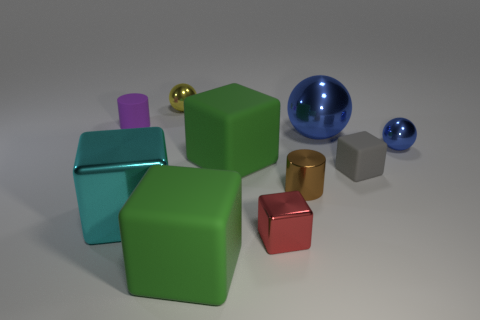There is a green thing in front of the metal thing on the left side of the small metallic thing that is behind the purple rubber thing; what is its material?
Ensure brevity in your answer.  Rubber. What is the size of the cube that is behind the red shiny cube and in front of the gray matte object?
Make the answer very short. Large. Is the shape of the tiny gray matte thing the same as the big blue metal thing?
Your response must be concise. No. What is the shape of the big cyan object that is the same material as the small red thing?
Offer a very short reply. Cube. What number of tiny things are either cylinders or yellow rubber spheres?
Give a very brief answer. 2. Is there a cylinder that is behind the big metallic object that is in front of the tiny blue ball?
Give a very brief answer. Yes. Is there a green rubber thing?
Your answer should be very brief. Yes. There is a small rubber thing left of the blue metal object that is behind the small blue metal sphere; what is its color?
Ensure brevity in your answer.  Purple. What material is the small red object that is the same shape as the small gray rubber object?
Your response must be concise. Metal. How many red things are the same size as the cyan block?
Ensure brevity in your answer.  0. 